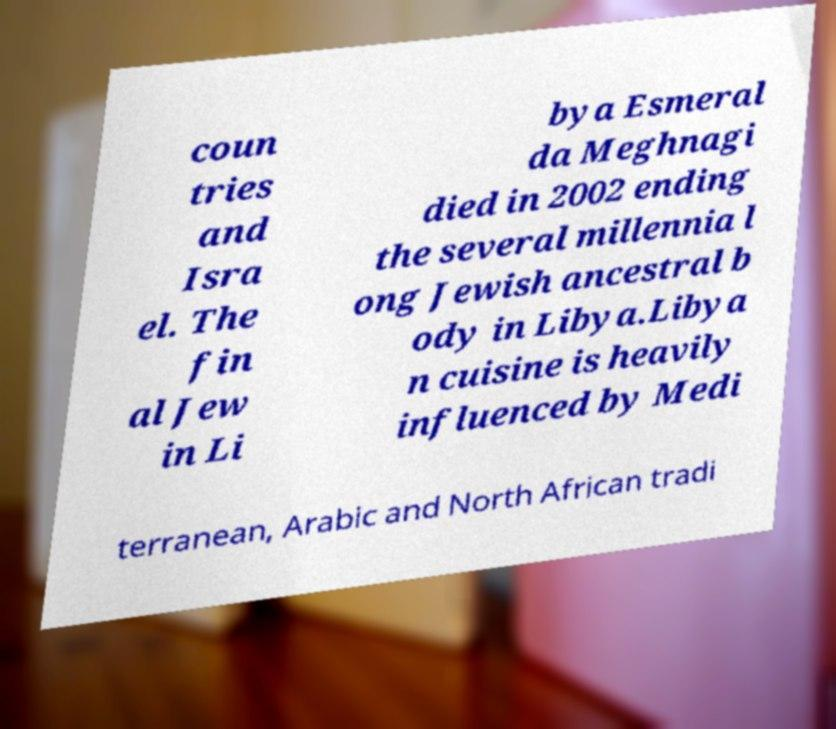For documentation purposes, I need the text within this image transcribed. Could you provide that? coun tries and Isra el. The fin al Jew in Li bya Esmeral da Meghnagi died in 2002 ending the several millennia l ong Jewish ancestral b ody in Libya.Libya n cuisine is heavily influenced by Medi terranean, Arabic and North African tradi 